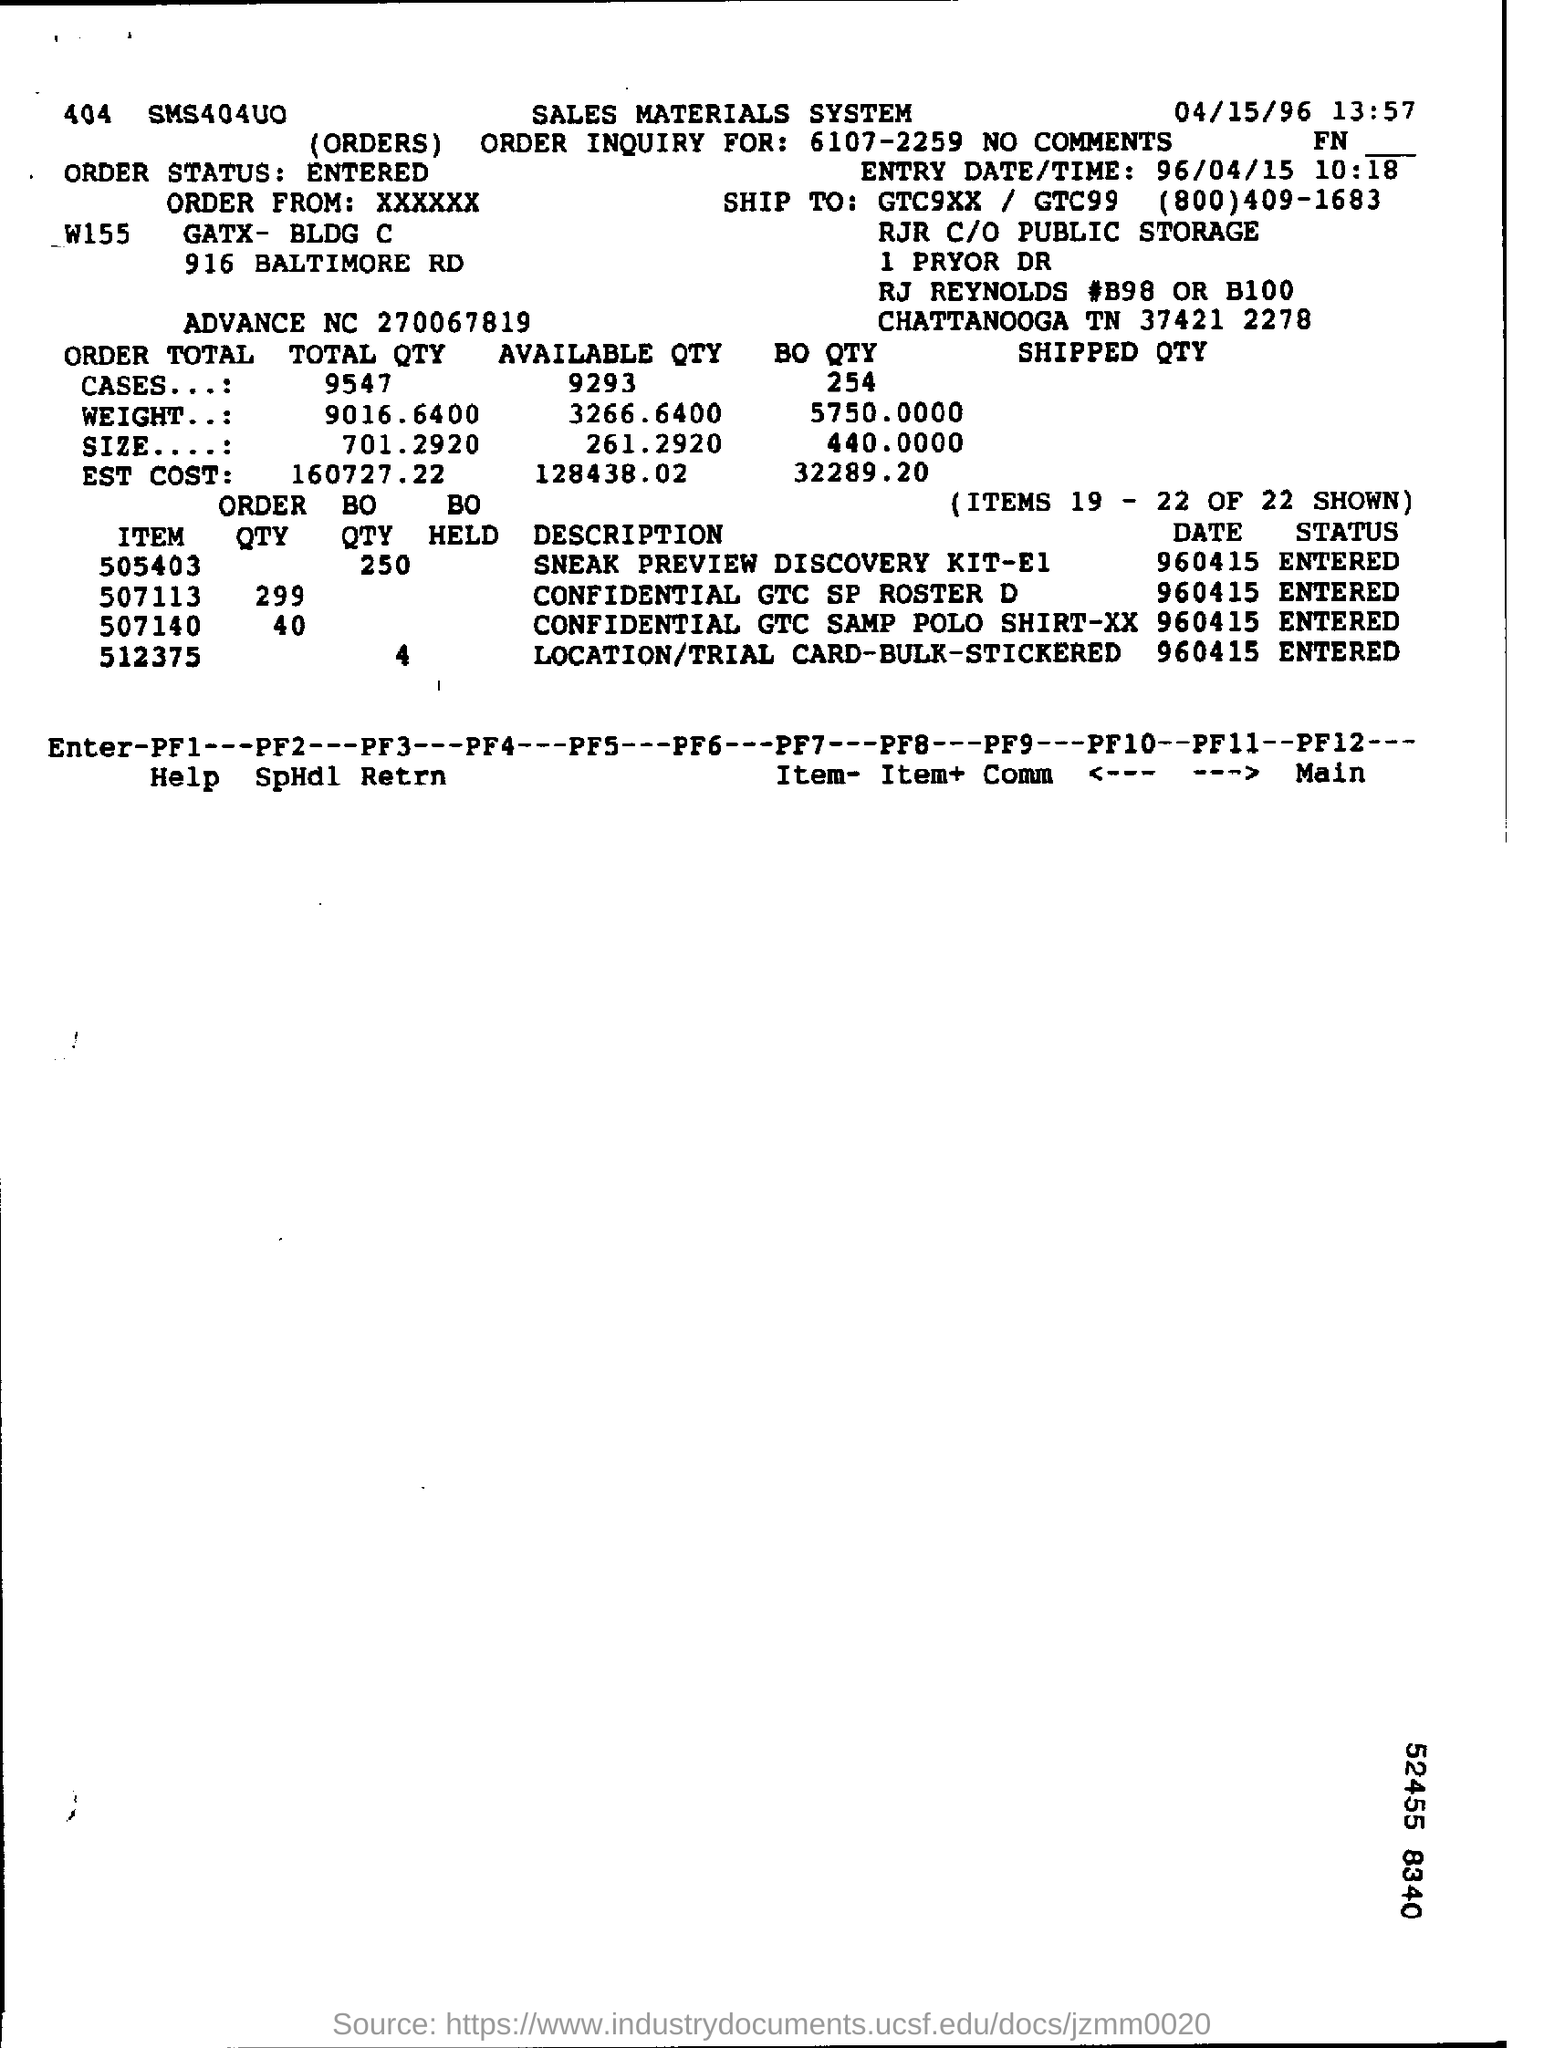List a handful of essential elements in this visual. The order quantity of 507113 is 299. The description of item number 505403 is a Sneak Preview Discovery Kit-E1. The entry date is April 15, 1996. 